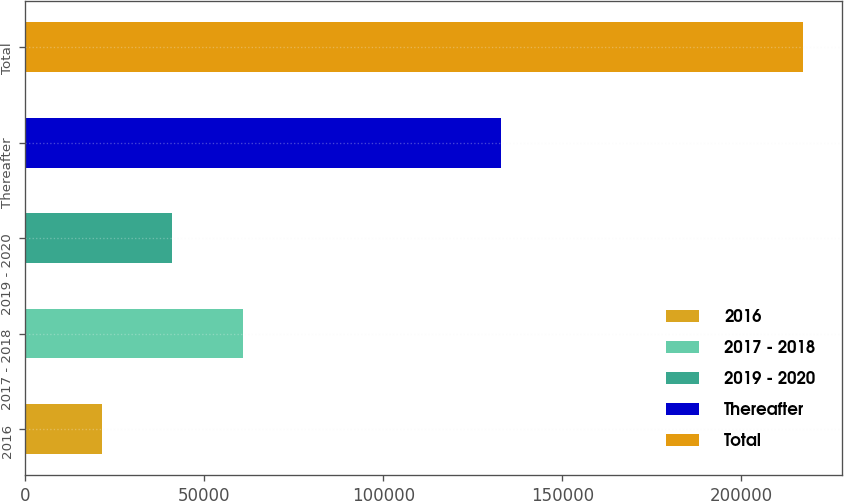Convert chart. <chart><loc_0><loc_0><loc_500><loc_500><bar_chart><fcel>2016<fcel>2017 - 2018<fcel>2019 - 2020<fcel>Thereafter<fcel>Total<nl><fcel>21479<fcel>60659.2<fcel>41069.1<fcel>132811<fcel>217380<nl></chart> 